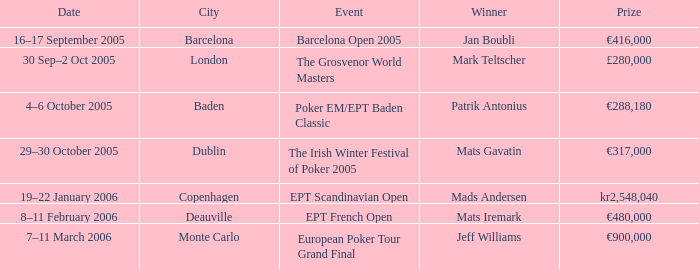When was the event in the City of Baden? 4–6 October 2005. 